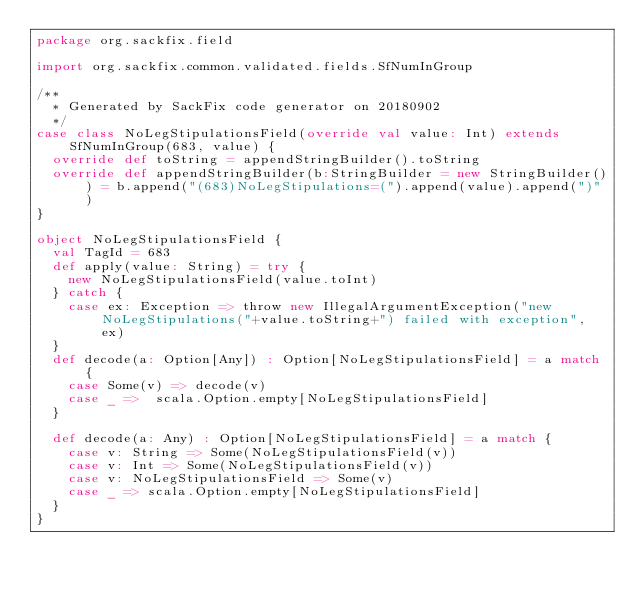Convert code to text. <code><loc_0><loc_0><loc_500><loc_500><_Scala_>package org.sackfix.field

import org.sackfix.common.validated.fields.SfNumInGroup

/**
  * Generated by SackFix code generator on 20180902
  */
case class NoLegStipulationsField(override val value: Int) extends SfNumInGroup(683, value) {
  override def toString = appendStringBuilder().toString
  override def appendStringBuilder(b:StringBuilder = new StringBuilder()) = b.append("(683)NoLegStipulations=(").append(value).append(")")
}

object NoLegStipulationsField {
  val TagId = 683  
  def apply(value: String) = try {
    new NoLegStipulationsField(value.toInt)
  } catch {
    case ex: Exception => throw new IllegalArgumentException("new NoLegStipulations("+value.toString+") failed with exception", ex)
  } 
  def decode(a: Option[Any]) : Option[NoLegStipulationsField] = a match {
    case Some(v) => decode(v)
    case _ =>  scala.Option.empty[NoLegStipulationsField]
  }

  def decode(a: Any) : Option[NoLegStipulationsField] = a match {
    case v: String => Some(NoLegStipulationsField(v))
    case v: Int => Some(NoLegStipulationsField(v))
    case v: NoLegStipulationsField => Some(v)
    case _ => scala.Option.empty[NoLegStipulationsField]
  } 
}
</code> 